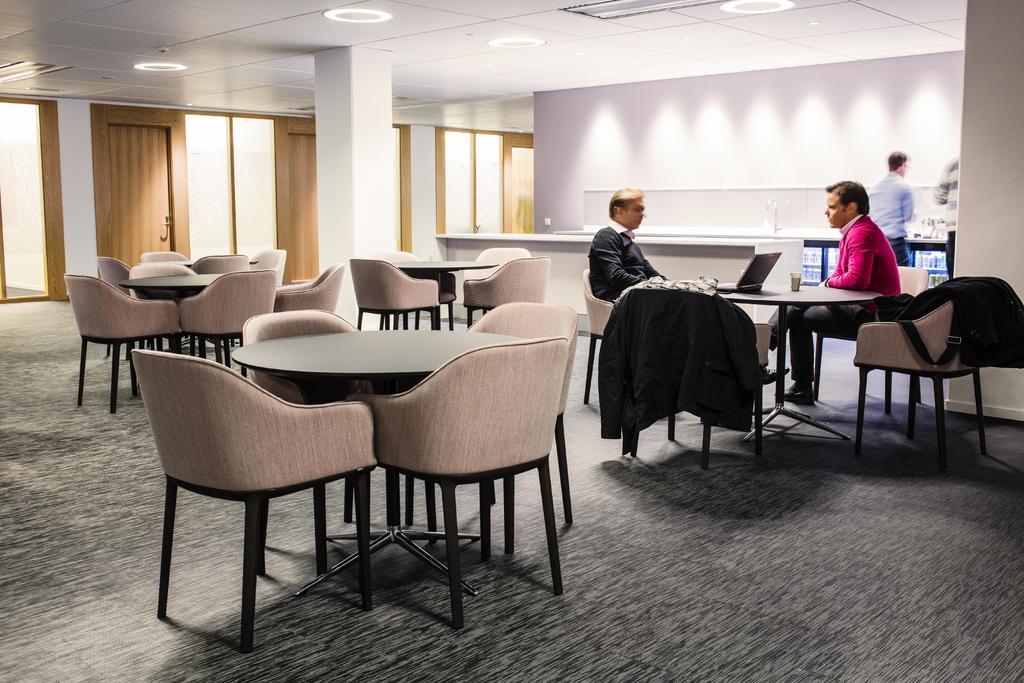Describe this image in one or two sentences. This picture might be taken in a office. In this picture there are many tables and chairs. In the top right there are two persons seated. On the table there is a laptop and a cup. On the top left there are doors. In the top right there is a wall and two person standing. On the top of the ceiling and lights attached to it. This is a edited picture. 